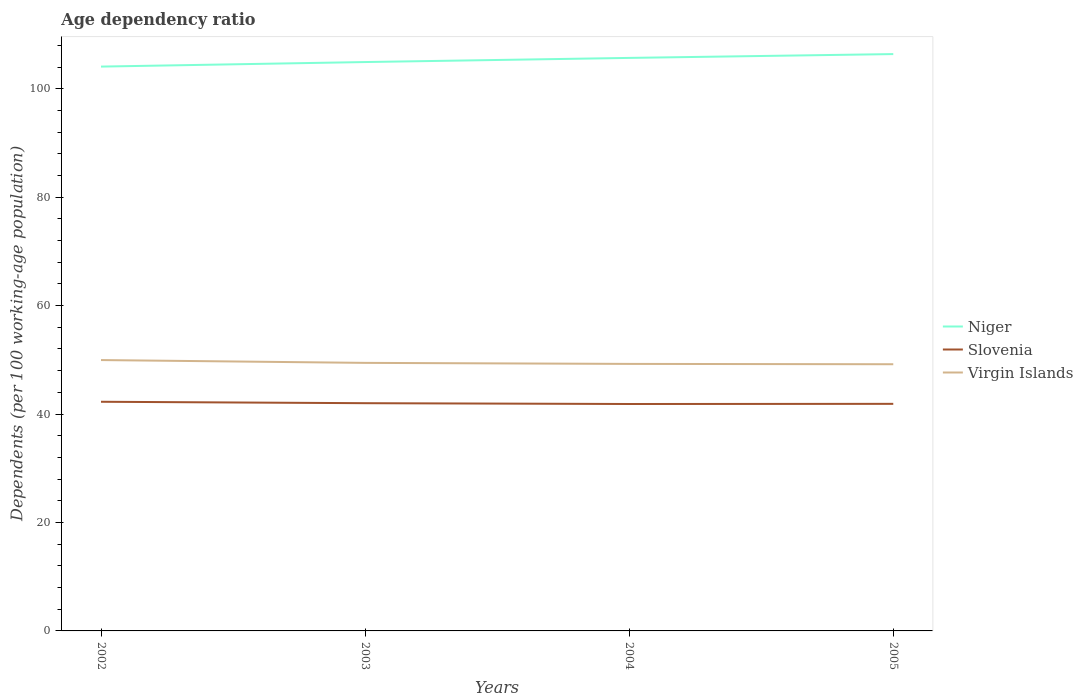Is the number of lines equal to the number of legend labels?
Give a very brief answer. Yes. Across all years, what is the maximum age dependency ratio in in Niger?
Provide a succinct answer. 104.08. What is the total age dependency ratio in in Niger in the graph?
Give a very brief answer. -1.6. What is the difference between the highest and the second highest age dependency ratio in in Slovenia?
Ensure brevity in your answer.  0.41. What is the difference between the highest and the lowest age dependency ratio in in Slovenia?
Ensure brevity in your answer.  2. Is the age dependency ratio in in Virgin Islands strictly greater than the age dependency ratio in in Niger over the years?
Ensure brevity in your answer.  Yes. How many lines are there?
Your response must be concise. 3. Are the values on the major ticks of Y-axis written in scientific E-notation?
Provide a short and direct response. No. Does the graph contain grids?
Ensure brevity in your answer.  No. Where does the legend appear in the graph?
Give a very brief answer. Center right. What is the title of the graph?
Keep it short and to the point. Age dependency ratio. Does "Seychelles" appear as one of the legend labels in the graph?
Make the answer very short. No. What is the label or title of the Y-axis?
Your answer should be compact. Dependents (per 100 working-age population). What is the Dependents (per 100 working-age population) in Niger in 2002?
Ensure brevity in your answer.  104.08. What is the Dependents (per 100 working-age population) of Slovenia in 2002?
Your response must be concise. 42.26. What is the Dependents (per 100 working-age population) of Virgin Islands in 2002?
Give a very brief answer. 49.96. What is the Dependents (per 100 working-age population) of Niger in 2003?
Provide a succinct answer. 104.92. What is the Dependents (per 100 working-age population) of Slovenia in 2003?
Make the answer very short. 42. What is the Dependents (per 100 working-age population) of Virgin Islands in 2003?
Provide a succinct answer. 49.44. What is the Dependents (per 100 working-age population) of Niger in 2004?
Provide a short and direct response. 105.68. What is the Dependents (per 100 working-age population) in Slovenia in 2004?
Provide a short and direct response. 41.85. What is the Dependents (per 100 working-age population) of Virgin Islands in 2004?
Your answer should be compact. 49.25. What is the Dependents (per 100 working-age population) in Niger in 2005?
Keep it short and to the point. 106.39. What is the Dependents (per 100 working-age population) in Slovenia in 2005?
Provide a short and direct response. 41.88. What is the Dependents (per 100 working-age population) of Virgin Islands in 2005?
Offer a very short reply. 49.19. Across all years, what is the maximum Dependents (per 100 working-age population) in Niger?
Give a very brief answer. 106.39. Across all years, what is the maximum Dependents (per 100 working-age population) of Slovenia?
Offer a terse response. 42.26. Across all years, what is the maximum Dependents (per 100 working-age population) of Virgin Islands?
Keep it short and to the point. 49.96. Across all years, what is the minimum Dependents (per 100 working-age population) in Niger?
Provide a succinct answer. 104.08. Across all years, what is the minimum Dependents (per 100 working-age population) in Slovenia?
Your response must be concise. 41.85. Across all years, what is the minimum Dependents (per 100 working-age population) of Virgin Islands?
Offer a very short reply. 49.19. What is the total Dependents (per 100 working-age population) in Niger in the graph?
Provide a succinct answer. 421.08. What is the total Dependents (per 100 working-age population) of Slovenia in the graph?
Offer a very short reply. 168. What is the total Dependents (per 100 working-age population) of Virgin Islands in the graph?
Provide a short and direct response. 197.83. What is the difference between the Dependents (per 100 working-age population) in Niger in 2002 and that in 2003?
Give a very brief answer. -0.84. What is the difference between the Dependents (per 100 working-age population) in Slovenia in 2002 and that in 2003?
Your answer should be very brief. 0.26. What is the difference between the Dependents (per 100 working-age population) of Virgin Islands in 2002 and that in 2003?
Ensure brevity in your answer.  0.52. What is the difference between the Dependents (per 100 working-age population) in Niger in 2002 and that in 2004?
Provide a succinct answer. -1.6. What is the difference between the Dependents (per 100 working-age population) of Slovenia in 2002 and that in 2004?
Offer a very short reply. 0.41. What is the difference between the Dependents (per 100 working-age population) of Virgin Islands in 2002 and that in 2004?
Offer a terse response. 0.71. What is the difference between the Dependents (per 100 working-age population) in Niger in 2002 and that in 2005?
Ensure brevity in your answer.  -2.31. What is the difference between the Dependents (per 100 working-age population) in Slovenia in 2002 and that in 2005?
Ensure brevity in your answer.  0.38. What is the difference between the Dependents (per 100 working-age population) of Virgin Islands in 2002 and that in 2005?
Make the answer very short. 0.77. What is the difference between the Dependents (per 100 working-age population) in Niger in 2003 and that in 2004?
Your answer should be very brief. -0.76. What is the difference between the Dependents (per 100 working-age population) in Slovenia in 2003 and that in 2004?
Provide a succinct answer. 0.15. What is the difference between the Dependents (per 100 working-age population) in Virgin Islands in 2003 and that in 2004?
Your answer should be compact. 0.19. What is the difference between the Dependents (per 100 working-age population) in Niger in 2003 and that in 2005?
Give a very brief answer. -1.47. What is the difference between the Dependents (per 100 working-age population) in Slovenia in 2003 and that in 2005?
Your response must be concise. 0.12. What is the difference between the Dependents (per 100 working-age population) in Virgin Islands in 2003 and that in 2005?
Give a very brief answer. 0.25. What is the difference between the Dependents (per 100 working-age population) of Niger in 2004 and that in 2005?
Ensure brevity in your answer.  -0.71. What is the difference between the Dependents (per 100 working-age population) of Slovenia in 2004 and that in 2005?
Your answer should be compact. -0.03. What is the difference between the Dependents (per 100 working-age population) in Virgin Islands in 2004 and that in 2005?
Provide a succinct answer. 0.06. What is the difference between the Dependents (per 100 working-age population) in Niger in 2002 and the Dependents (per 100 working-age population) in Slovenia in 2003?
Keep it short and to the point. 62.08. What is the difference between the Dependents (per 100 working-age population) of Niger in 2002 and the Dependents (per 100 working-age population) of Virgin Islands in 2003?
Your answer should be compact. 54.65. What is the difference between the Dependents (per 100 working-age population) of Slovenia in 2002 and the Dependents (per 100 working-age population) of Virgin Islands in 2003?
Give a very brief answer. -7.17. What is the difference between the Dependents (per 100 working-age population) of Niger in 2002 and the Dependents (per 100 working-age population) of Slovenia in 2004?
Your answer should be very brief. 62.23. What is the difference between the Dependents (per 100 working-age population) of Niger in 2002 and the Dependents (per 100 working-age population) of Virgin Islands in 2004?
Make the answer very short. 54.83. What is the difference between the Dependents (per 100 working-age population) of Slovenia in 2002 and the Dependents (per 100 working-age population) of Virgin Islands in 2004?
Keep it short and to the point. -6.98. What is the difference between the Dependents (per 100 working-age population) in Niger in 2002 and the Dependents (per 100 working-age population) in Slovenia in 2005?
Ensure brevity in your answer.  62.2. What is the difference between the Dependents (per 100 working-age population) of Niger in 2002 and the Dependents (per 100 working-age population) of Virgin Islands in 2005?
Provide a succinct answer. 54.89. What is the difference between the Dependents (per 100 working-age population) in Slovenia in 2002 and the Dependents (per 100 working-age population) in Virgin Islands in 2005?
Ensure brevity in your answer.  -6.92. What is the difference between the Dependents (per 100 working-age population) in Niger in 2003 and the Dependents (per 100 working-age population) in Slovenia in 2004?
Give a very brief answer. 63.07. What is the difference between the Dependents (per 100 working-age population) of Niger in 2003 and the Dependents (per 100 working-age population) of Virgin Islands in 2004?
Your answer should be compact. 55.67. What is the difference between the Dependents (per 100 working-age population) in Slovenia in 2003 and the Dependents (per 100 working-age population) in Virgin Islands in 2004?
Ensure brevity in your answer.  -7.24. What is the difference between the Dependents (per 100 working-age population) of Niger in 2003 and the Dependents (per 100 working-age population) of Slovenia in 2005?
Offer a very short reply. 63.04. What is the difference between the Dependents (per 100 working-age population) in Niger in 2003 and the Dependents (per 100 working-age population) in Virgin Islands in 2005?
Your answer should be compact. 55.73. What is the difference between the Dependents (per 100 working-age population) of Slovenia in 2003 and the Dependents (per 100 working-age population) of Virgin Islands in 2005?
Your response must be concise. -7.18. What is the difference between the Dependents (per 100 working-age population) of Niger in 2004 and the Dependents (per 100 working-age population) of Slovenia in 2005?
Your answer should be compact. 63.8. What is the difference between the Dependents (per 100 working-age population) of Niger in 2004 and the Dependents (per 100 working-age population) of Virgin Islands in 2005?
Offer a terse response. 56.5. What is the difference between the Dependents (per 100 working-age population) of Slovenia in 2004 and the Dependents (per 100 working-age population) of Virgin Islands in 2005?
Make the answer very short. -7.33. What is the average Dependents (per 100 working-age population) of Niger per year?
Give a very brief answer. 105.27. What is the average Dependents (per 100 working-age population) of Slovenia per year?
Your answer should be compact. 42. What is the average Dependents (per 100 working-age population) in Virgin Islands per year?
Your answer should be compact. 49.46. In the year 2002, what is the difference between the Dependents (per 100 working-age population) of Niger and Dependents (per 100 working-age population) of Slovenia?
Ensure brevity in your answer.  61.82. In the year 2002, what is the difference between the Dependents (per 100 working-age population) of Niger and Dependents (per 100 working-age population) of Virgin Islands?
Offer a very short reply. 54.13. In the year 2002, what is the difference between the Dependents (per 100 working-age population) in Slovenia and Dependents (per 100 working-age population) in Virgin Islands?
Offer a very short reply. -7.69. In the year 2003, what is the difference between the Dependents (per 100 working-age population) of Niger and Dependents (per 100 working-age population) of Slovenia?
Your answer should be very brief. 62.92. In the year 2003, what is the difference between the Dependents (per 100 working-age population) of Niger and Dependents (per 100 working-age population) of Virgin Islands?
Your answer should be very brief. 55.48. In the year 2003, what is the difference between the Dependents (per 100 working-age population) in Slovenia and Dependents (per 100 working-age population) in Virgin Islands?
Offer a very short reply. -7.43. In the year 2004, what is the difference between the Dependents (per 100 working-age population) in Niger and Dependents (per 100 working-age population) in Slovenia?
Keep it short and to the point. 63.83. In the year 2004, what is the difference between the Dependents (per 100 working-age population) of Niger and Dependents (per 100 working-age population) of Virgin Islands?
Ensure brevity in your answer.  56.44. In the year 2004, what is the difference between the Dependents (per 100 working-age population) of Slovenia and Dependents (per 100 working-age population) of Virgin Islands?
Offer a very short reply. -7.39. In the year 2005, what is the difference between the Dependents (per 100 working-age population) in Niger and Dependents (per 100 working-age population) in Slovenia?
Your response must be concise. 64.51. In the year 2005, what is the difference between the Dependents (per 100 working-age population) in Niger and Dependents (per 100 working-age population) in Virgin Islands?
Make the answer very short. 57.2. In the year 2005, what is the difference between the Dependents (per 100 working-age population) of Slovenia and Dependents (per 100 working-age population) of Virgin Islands?
Give a very brief answer. -7.31. What is the ratio of the Dependents (per 100 working-age population) in Virgin Islands in 2002 to that in 2003?
Your answer should be compact. 1.01. What is the ratio of the Dependents (per 100 working-age population) in Niger in 2002 to that in 2004?
Offer a very short reply. 0.98. What is the ratio of the Dependents (per 100 working-age population) of Slovenia in 2002 to that in 2004?
Your answer should be compact. 1.01. What is the ratio of the Dependents (per 100 working-age population) of Virgin Islands in 2002 to that in 2004?
Ensure brevity in your answer.  1.01. What is the ratio of the Dependents (per 100 working-age population) of Niger in 2002 to that in 2005?
Make the answer very short. 0.98. What is the ratio of the Dependents (per 100 working-age population) of Slovenia in 2002 to that in 2005?
Give a very brief answer. 1.01. What is the ratio of the Dependents (per 100 working-age population) in Virgin Islands in 2002 to that in 2005?
Keep it short and to the point. 1.02. What is the ratio of the Dependents (per 100 working-age population) in Niger in 2003 to that in 2005?
Offer a very short reply. 0.99. What is the ratio of the Dependents (per 100 working-age population) of Virgin Islands in 2003 to that in 2005?
Provide a short and direct response. 1.01. What is the ratio of the Dependents (per 100 working-age population) in Slovenia in 2004 to that in 2005?
Your response must be concise. 1. What is the difference between the highest and the second highest Dependents (per 100 working-age population) of Niger?
Your answer should be compact. 0.71. What is the difference between the highest and the second highest Dependents (per 100 working-age population) in Slovenia?
Provide a succinct answer. 0.26. What is the difference between the highest and the second highest Dependents (per 100 working-age population) of Virgin Islands?
Your answer should be compact. 0.52. What is the difference between the highest and the lowest Dependents (per 100 working-age population) of Niger?
Your answer should be compact. 2.31. What is the difference between the highest and the lowest Dependents (per 100 working-age population) of Slovenia?
Make the answer very short. 0.41. What is the difference between the highest and the lowest Dependents (per 100 working-age population) of Virgin Islands?
Give a very brief answer. 0.77. 